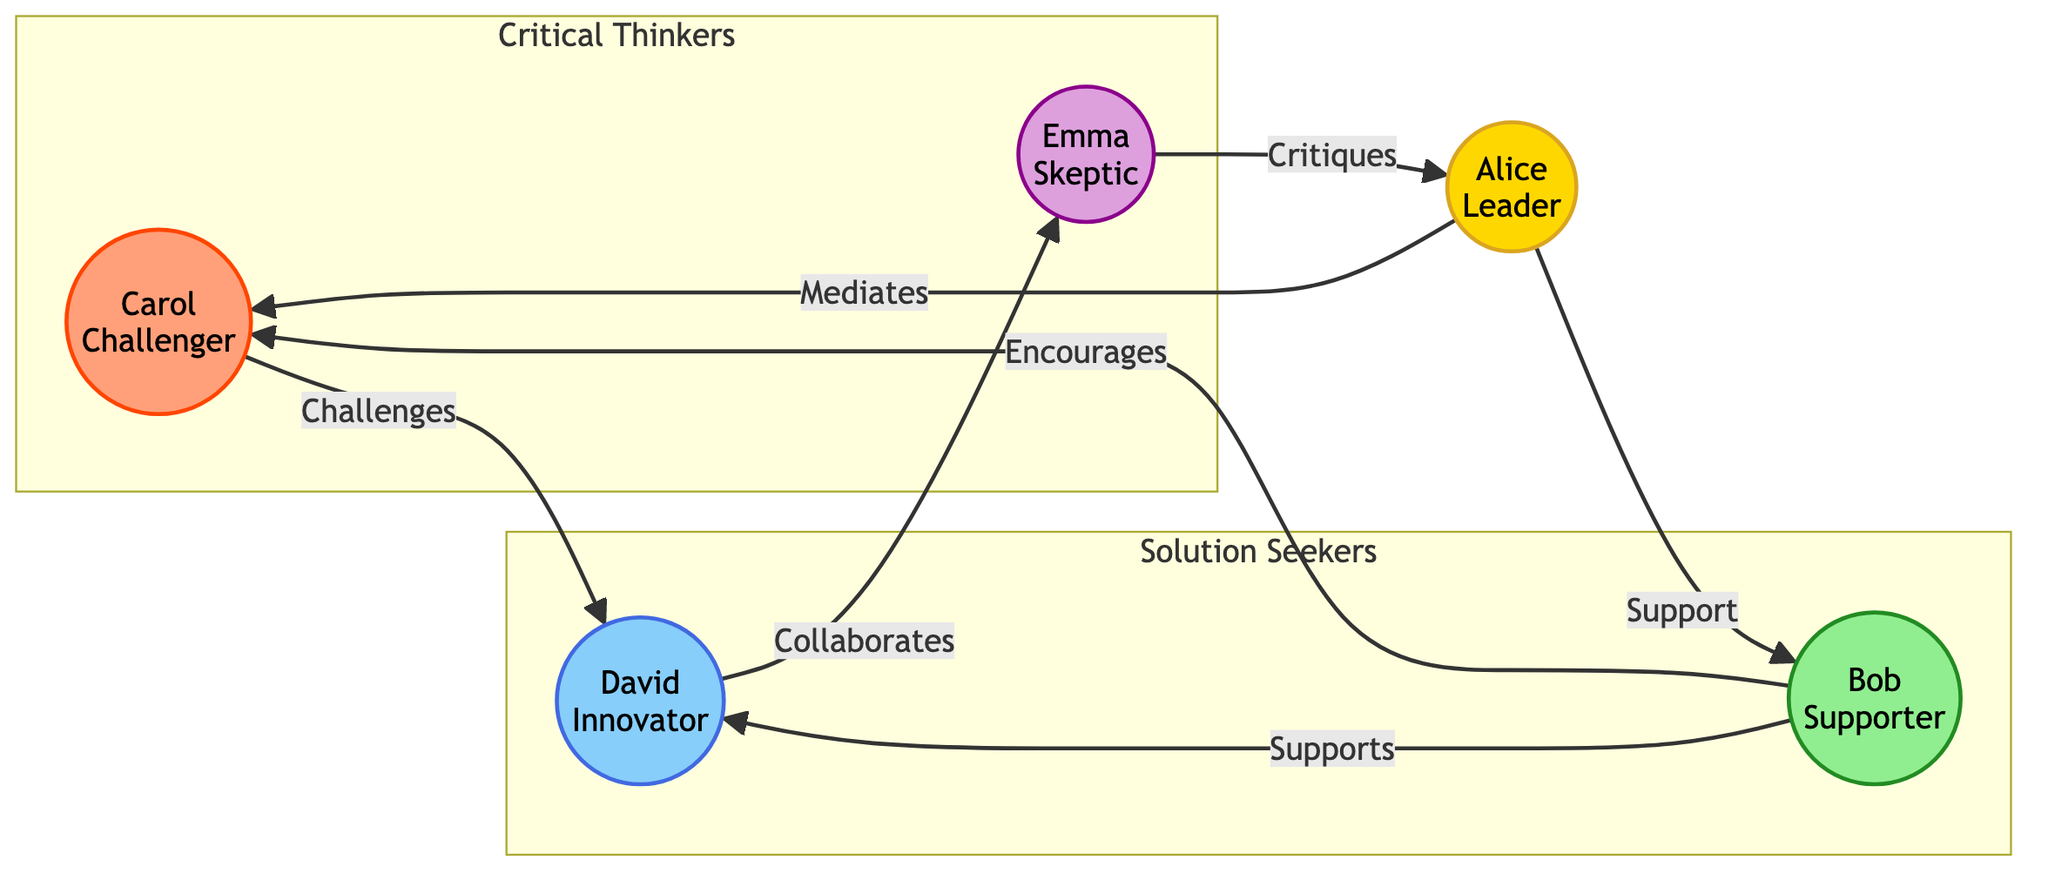What is the role of Alice in the group? Alice is labeled as the "Leader" in the diagram, which indicates her primary role in the group dynamics.
Answer: Leader How many members are in the "Solution Seekers" sub-group? The "Solution Seekers" sub-group consists of two members, Bob and David, as shown under that section of the diagram.
Answer: 2 Which member critiques Alice? The diagram indicates that Emma critiques Alice, as there is a directed edge from Emma to Alice labeled "Critiques".
Answer: Emma What type of relationship exists between Bob and Carol? Bob and Carol have a supportive relationship, as indicated by the directed edge from Bob to Carol with the label "Encourages".
Answer: Encourages Which two members belong to the "Critical Thinkers" sub-group? The sub-group "Critical Thinkers" includes Carol and Emma, as specified in the subgraph section of the diagram.
Answer: Carol, Emma How many edges are in the diagram? By counting the directed connections between members, there are a total of six edges that show the relationships among the members.
Answer: 6 Which member has a collaborative relationship with Emma? The directed edge shows that David collaborates with Emma, as indicated by the connection labeled "Collaborates".
Answer: David Who is the challenger in the group dynamics? Carol is designated as the "Challenger" in the diagram, which highlights her role in questioning or challenging ideas within the group.
Answer: Carol What is the supporting role that Bob plays towards David? According to the diagram, Bob plays the role of "Supports" towards David, as indicated by the connection labeled "Supports".
Answer: Supports What color represents the skeptics in the diagram? The skeptics are represented by the color purple as seen in the "Emma" node, which has the class definition "skeptic" associated with a purple fill.
Answer: Purple 